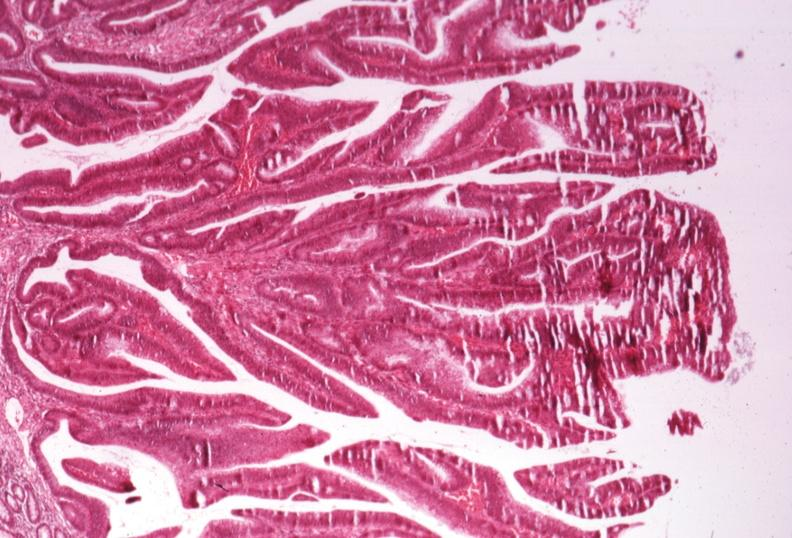s very good example present?
Answer the question using a single word or phrase. No 